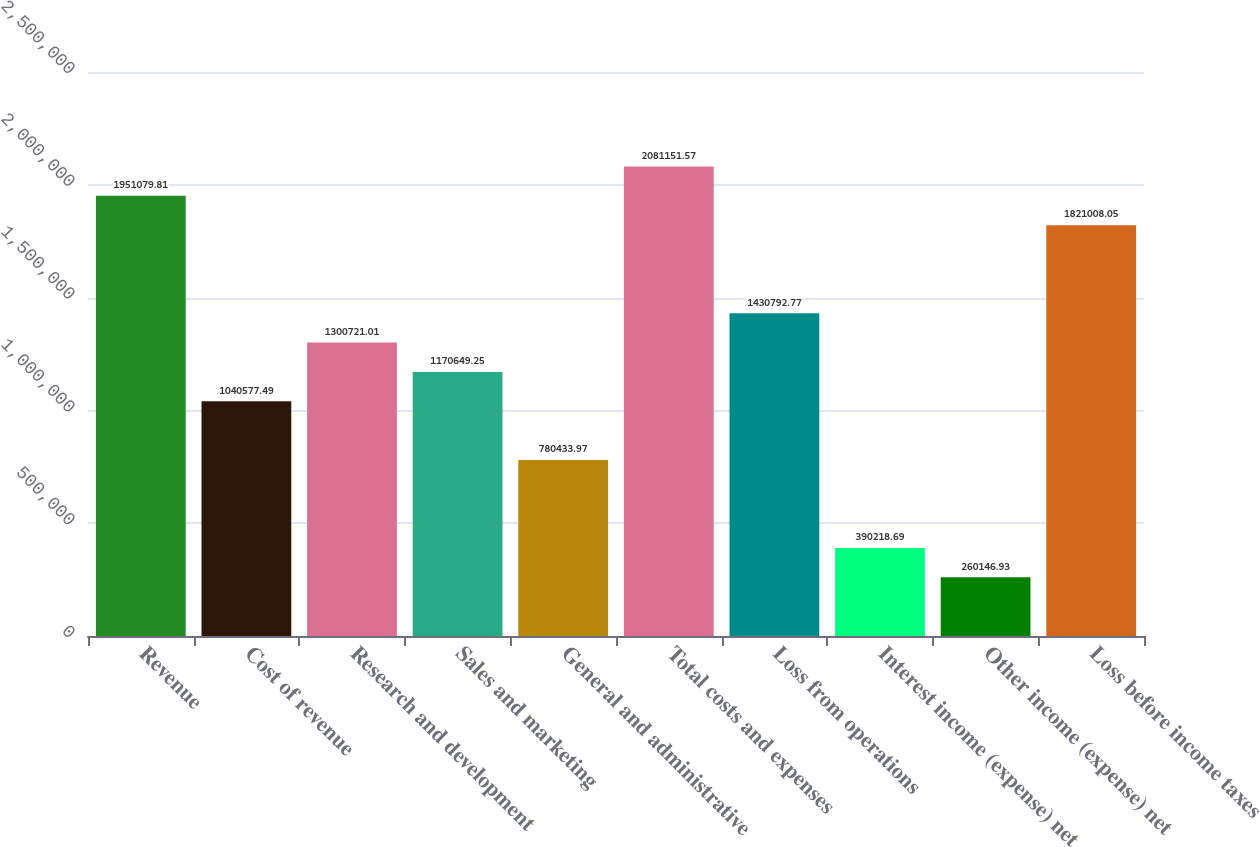Convert chart. <chart><loc_0><loc_0><loc_500><loc_500><bar_chart><fcel>Revenue<fcel>Cost of revenue<fcel>Research and development<fcel>Sales and marketing<fcel>General and administrative<fcel>Total costs and expenses<fcel>Loss from operations<fcel>Interest income (expense) net<fcel>Other income (expense) net<fcel>Loss before income taxes<nl><fcel>1.95108e+06<fcel>1.04058e+06<fcel>1.30072e+06<fcel>1.17065e+06<fcel>780434<fcel>2.08115e+06<fcel>1.43079e+06<fcel>390219<fcel>260147<fcel>1.82101e+06<nl></chart> 